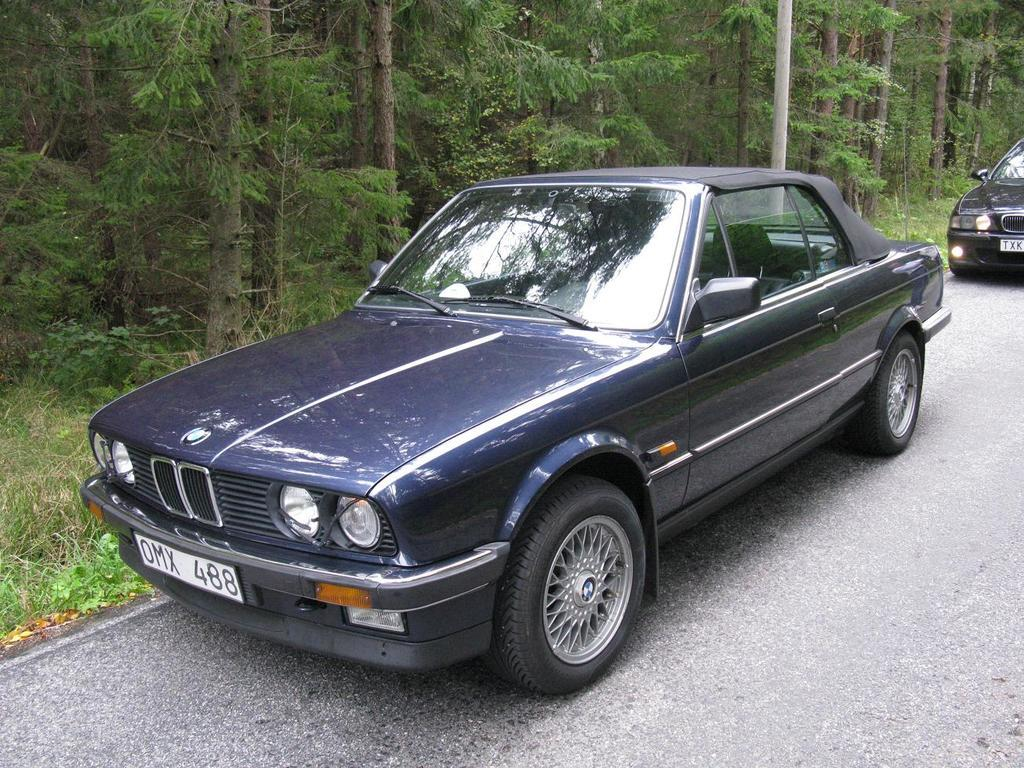What type of vehicles can be seen on the road in the image? There are cars on the road in the image. What natural elements are present in the image? There are trees and grass in the image. What man-made object can be seen in the image? There is a pole in the image. Can you tell me how many doctors are present in the image? There are no doctors present in the image. What type of chin can be seen on the person in the image? There is no person or chin present in the image. 